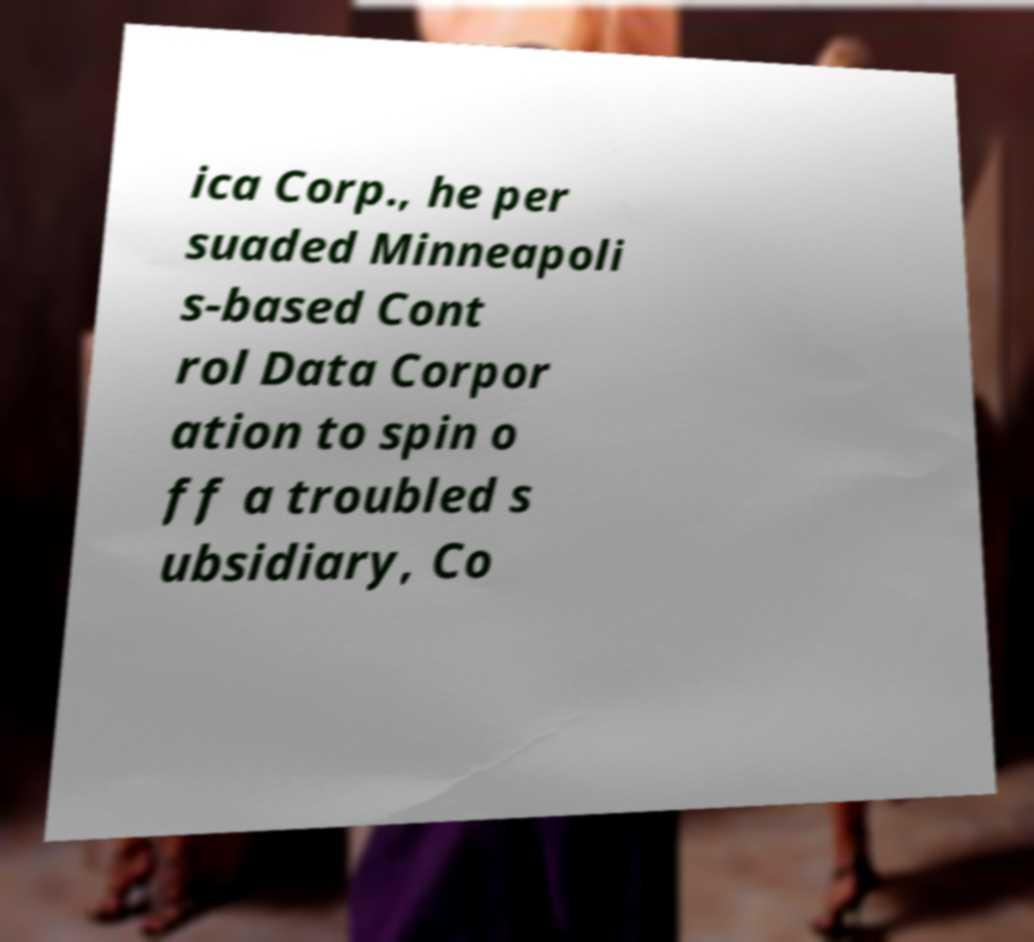Can you accurately transcribe the text from the provided image for me? ica Corp., he per suaded Minneapoli s-based Cont rol Data Corpor ation to spin o ff a troubled s ubsidiary, Co 